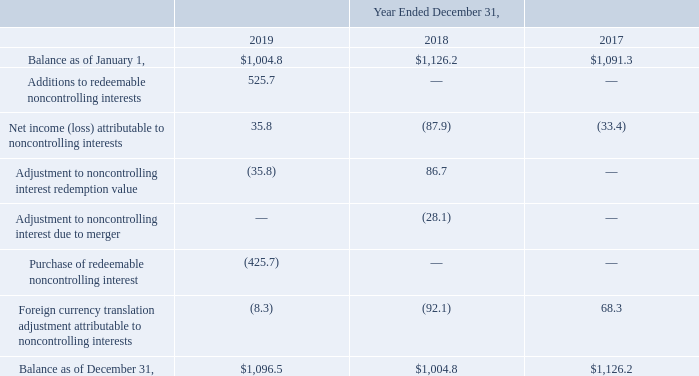AMERICAN TOWER CORPORATION AND SUBSIDIARIES NOTES TO CONSOLIDATED FINANCIAL STATEMENTS (Tabular amounts in millions, unless otherwise disclosed)
Other Redeemable Noncontrolling Interests—During the year ended December 31, 2019, the Company entered into an agreement with MTN to acquire MTN’s noncontrolling interests in each of the Company’s joint ventures in Ghana and Uganda for total consideration of approximately $523.0 million. The transaction is expected to close in the first quarter of 2020, subject to regulatory approval and other closing conditions. In addition, the Company, through a subsidiary of ATC Europe, entered into an agreement with its local partners in France to form Eure-et-Loir Réseaux Mobiles SAS (“Eure-et-Loir”), a telecommunications infrastructure company that owns and operates wireless communications towers in France. The Company’s controlling interest in Eure-et-Loir is 51% with local partners holding a 49% noncontrolling interest. The agreement provides the local partners with put options, which allow them to sell outstanding shares of Eure-et-Loir to the Company, and the Company with call options, which allow it to buy the noncontrolling shares of Eure-et-Loir. The put options, which are not under the Company’s control, cannot be separated from the noncontrolling interests. As a result, the combination of the noncontrolling interests and the redemption feature requires classification as redeemable noncontrolling interests in the consolidated balance sheet, separate from equity. The value of the Eure-et-Loir interests as of December 31, 2019 was $2.7 million.
The changes in Redeemable noncontrolling interests for the years ended December 31, 2019, 2018 and 2017 were as follows:
What was the value of the Eure-et-Loir interests as of December 31, 2019? $2.7 million. What was the balance as of January 1 in 2019?
Answer scale should be: million. $1,004.8. What was the Net income (loss) attributable to noncontrolling interests in 2017?
Answer scale should be: million. (33.4). What was the change in balance as of January 1 between 2017 and 2018?
Answer scale should be: million. $1,126.2-$1,091.3
Answer: 34.9. What was the change in Adjustment to noncontrolling interest redemption value between 2018 and 2019?
Answer scale should be: million. -35.8-86.7
Answer: -122.5. What was the percentage change in balance as of December 31 between 2018 and 2019?
Answer scale should be: percent. ($1,096.5-$1,004.8)/$1,004.8
Answer: 9.13. 